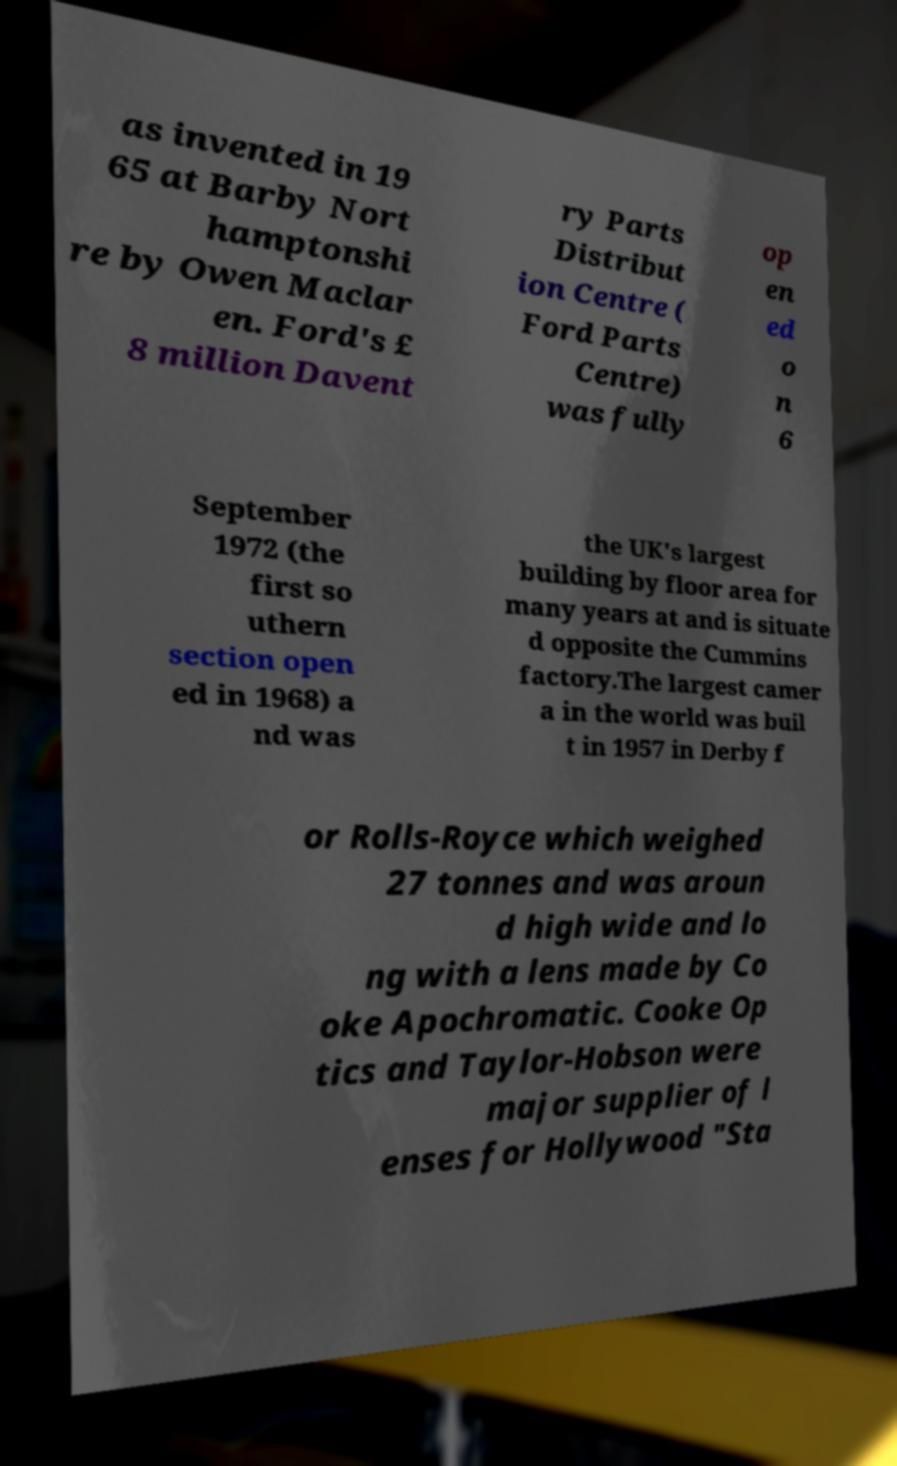What messages or text are displayed in this image? I need them in a readable, typed format. as invented in 19 65 at Barby Nort hamptonshi re by Owen Maclar en. Ford's £ 8 million Davent ry Parts Distribut ion Centre ( Ford Parts Centre) was fully op en ed o n 6 September 1972 (the first so uthern section open ed in 1968) a nd was the UK's largest building by floor area for many years at and is situate d opposite the Cummins factory.The largest camer a in the world was buil t in 1957 in Derby f or Rolls-Royce which weighed 27 tonnes and was aroun d high wide and lo ng with a lens made by Co oke Apochromatic. Cooke Op tics and Taylor-Hobson were major supplier of l enses for Hollywood "Sta 